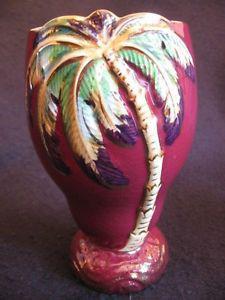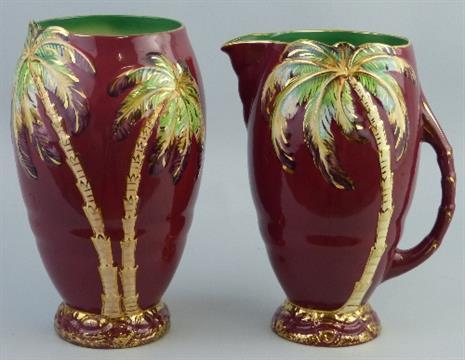The first image is the image on the left, the second image is the image on the right. For the images shown, is this caption "There is at least 1 blue decorative vase with a palm tree on it." true? Answer yes or no. No. The first image is the image on the left, the second image is the image on the right. Analyze the images presented: Is the assertion "the right image contains a pitcher with a handle" valid? Answer yes or no. Yes. 